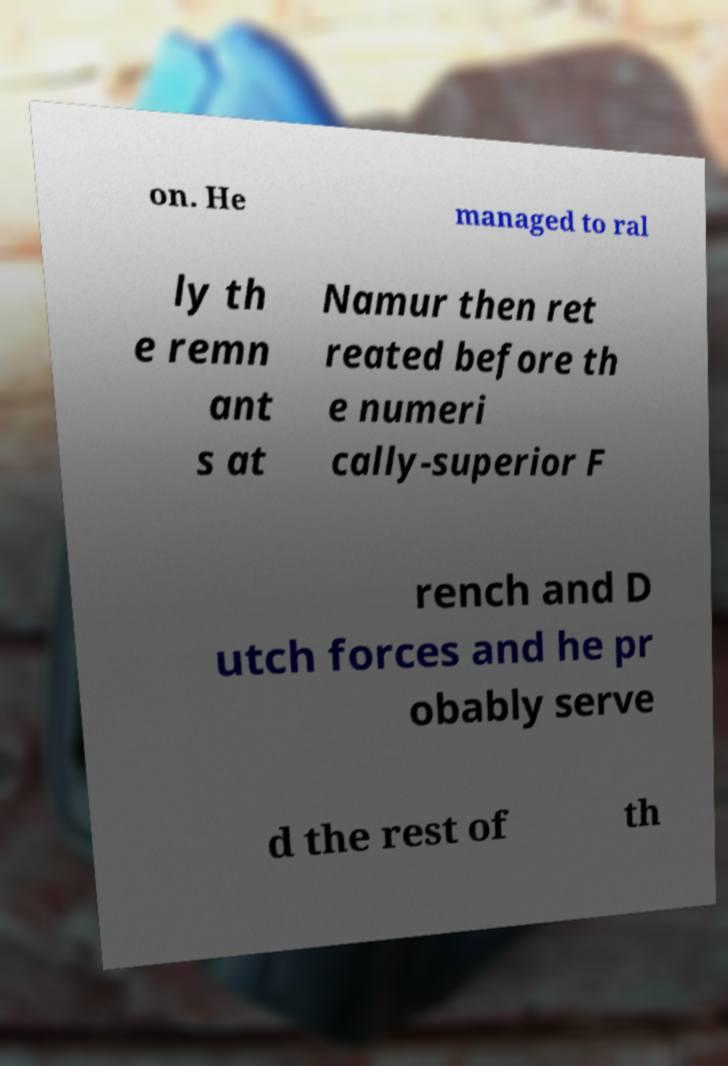I need the written content from this picture converted into text. Can you do that? on. He managed to ral ly th e remn ant s at Namur then ret reated before th e numeri cally-superior F rench and D utch forces and he pr obably serve d the rest of th 